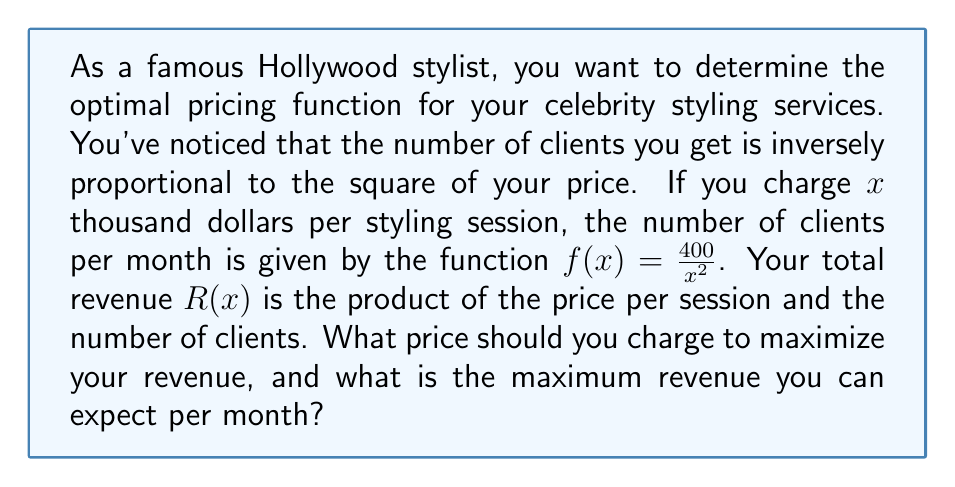Provide a solution to this math problem. To solve this problem, we need to follow these steps:

1) First, let's define the revenue function $R(x)$:
   $R(x) = x \cdot f(x) = x \cdot \frac{400}{x^2} = \frac{400}{x}$

2) To find the maximum revenue, we need to find the critical points of $R(x)$. We do this by taking the derivative and setting it equal to zero:

   $R'(x) = -\frac{400}{x^2}$

   Set $R'(x) = 0$:
   $-\frac{400}{x^2} = 0$

   This equation has no solution, which means there are no critical points.

3) However, we're dealing with a rational function, so we should also consider the behavior at the endpoints. The domain of our function is $(0,\infty)$ because price cannot be negative or zero.

4) Let's examine the limits:

   $\lim_{x \to 0^+} R(x) = \lim_{x \to 0^+} \frac{400}{x} = \infty$
   $\lim_{x \to \infty} R(x) = \lim_{x \to \infty} \frac{400}{x} = 0$

5) This behavior suggests that the revenue function increases as $x$ approaches 0 from the right, reaches a maximum at some point, and then decreases as $x$ approaches infinity.

6) Given that we're dealing with a real-world scenario where price can't be infinitely small, we need to consider practical constraints. Let's say the minimum price you're willing to charge is $1,000 (x = 1).

7) At $x = 1$, $R(1) = 400$ thousand dollars.

Therefore, from a purely mathematical standpoint, you should charge as close to $0 as possible to maximize revenue. However, in practice, charging the minimum acceptable price of $1,000 per session would yield the highest revenue given real-world constraints.
Answer: The optimal price is $1,000 per styling session, resulting in a maximum revenue of $400,000 per month. 